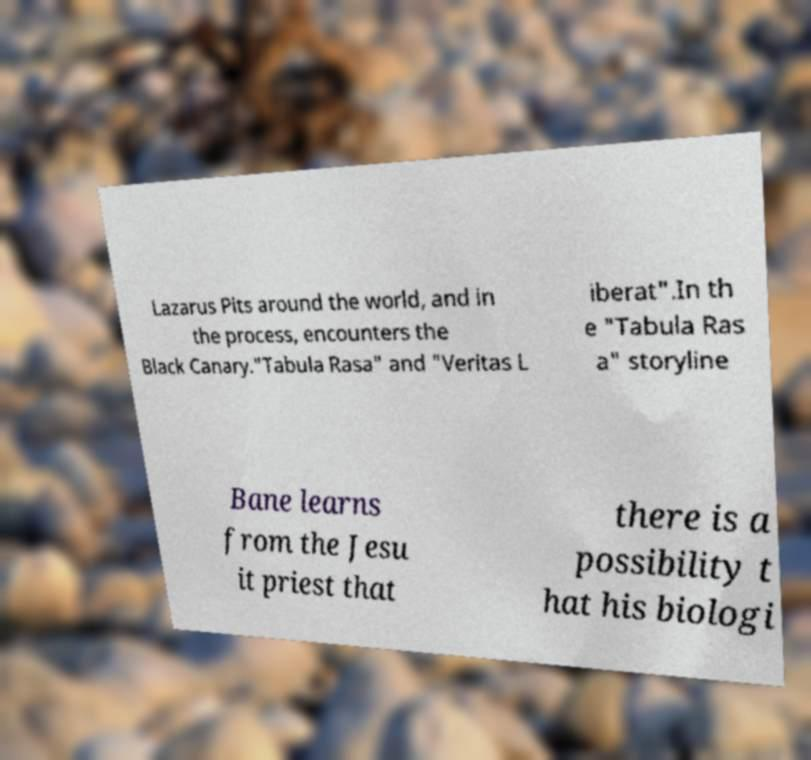Can you read and provide the text displayed in the image?This photo seems to have some interesting text. Can you extract and type it out for me? Lazarus Pits around the world, and in the process, encounters the Black Canary."Tabula Rasa" and "Veritas L iberat".In th e "Tabula Ras a" storyline Bane learns from the Jesu it priest that there is a possibility t hat his biologi 